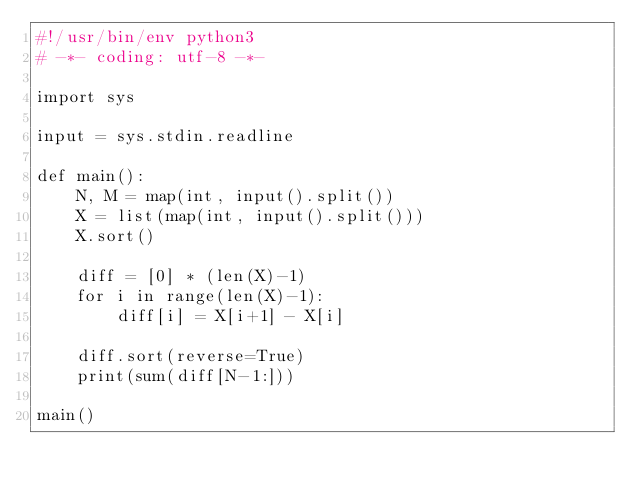<code> <loc_0><loc_0><loc_500><loc_500><_Python_>#!/usr/bin/env python3
# -*- coding: utf-8 -*-

import sys

input = sys.stdin.readline

def main():
    N, M = map(int, input().split())
    X = list(map(int, input().split()))
    X.sort()

    diff = [0] * (len(X)-1)
    for i in range(len(X)-1):
        diff[i] = X[i+1] - X[i]

    diff.sort(reverse=True)
    print(sum(diff[N-1:]))

main()
</code> 